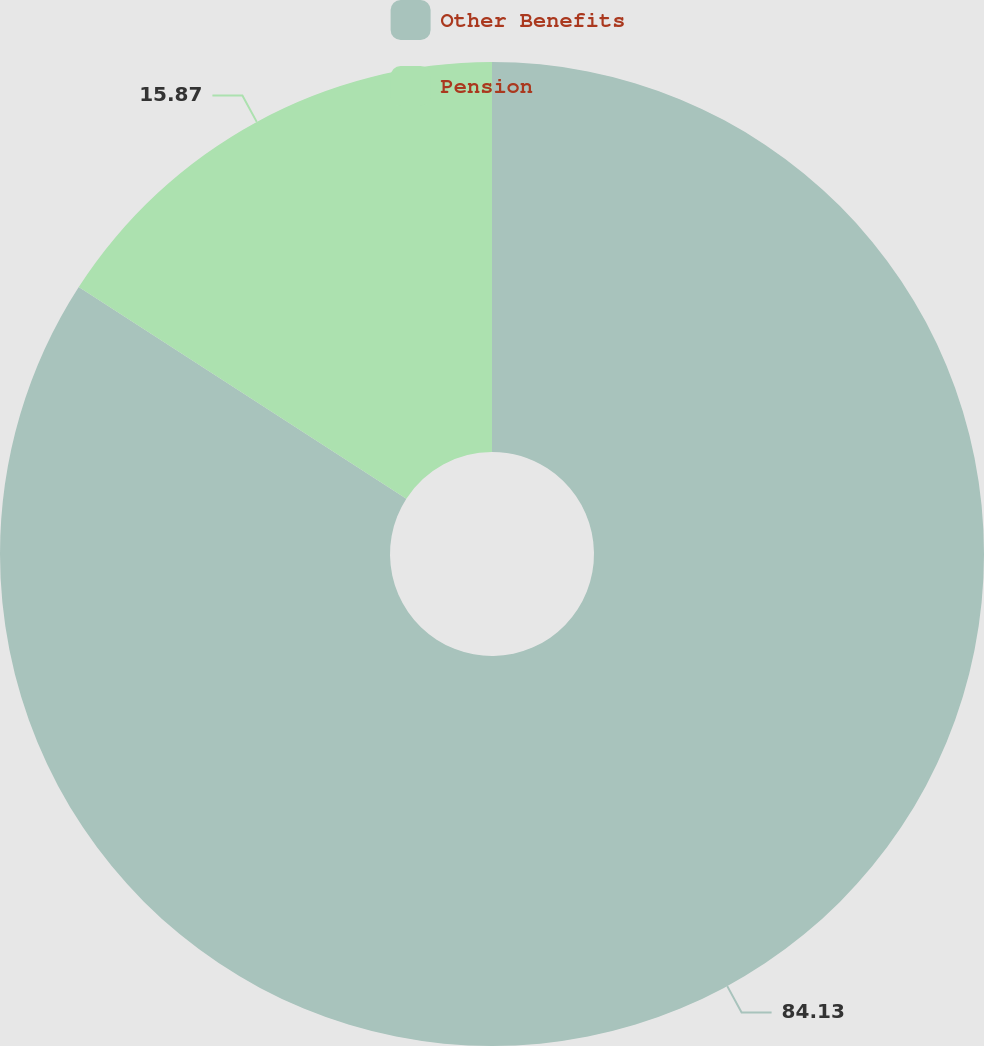<chart> <loc_0><loc_0><loc_500><loc_500><pie_chart><fcel>Other Benefits<fcel>Pension<nl><fcel>84.13%<fcel>15.87%<nl></chart> 